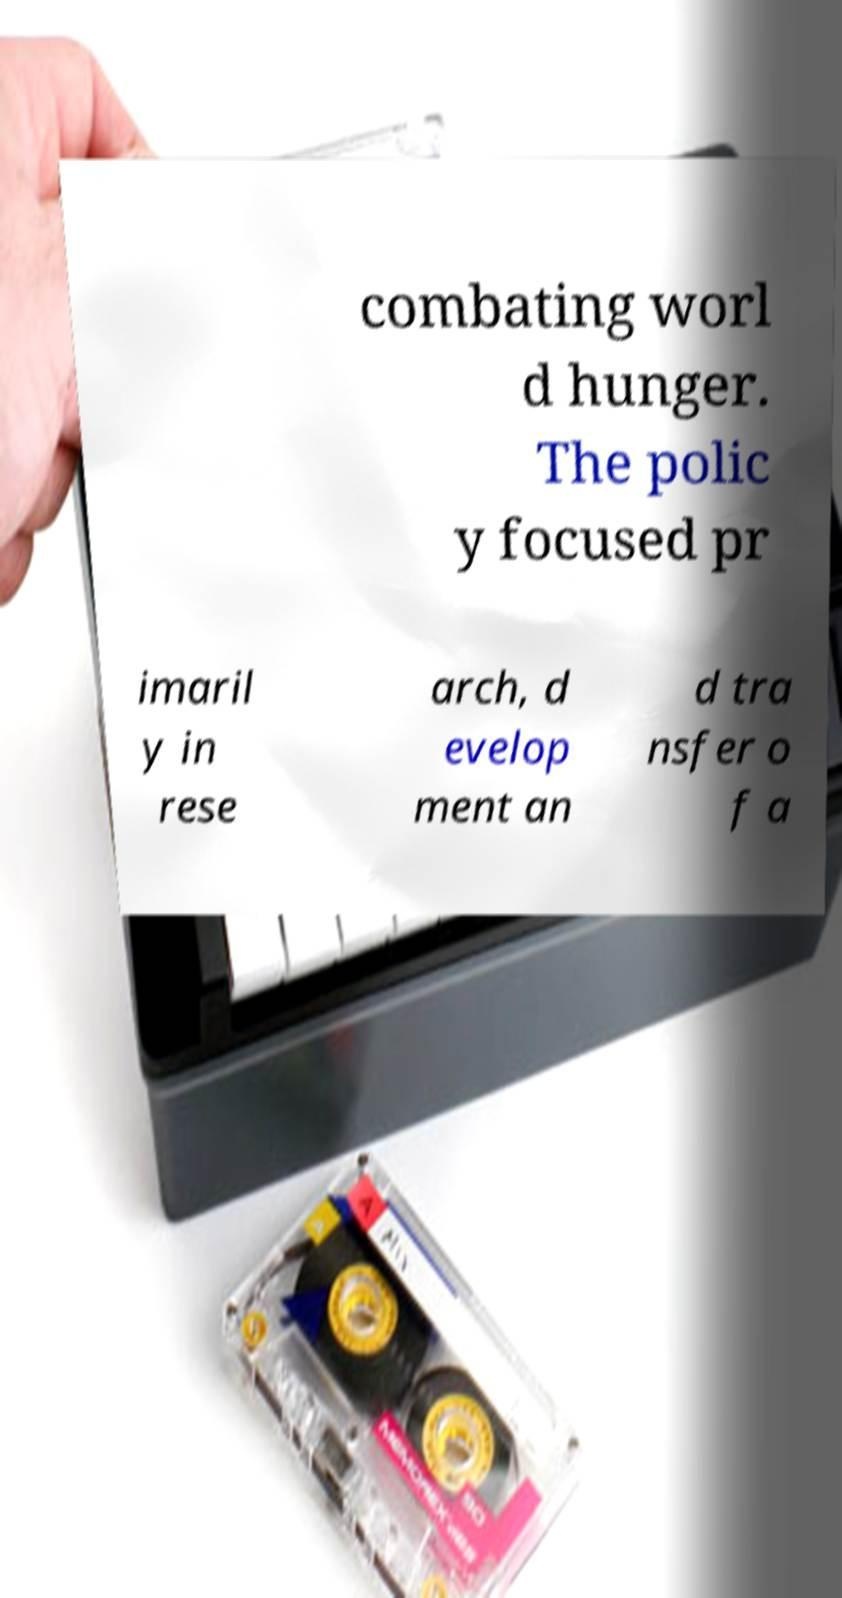Can you read and provide the text displayed in the image?This photo seems to have some interesting text. Can you extract and type it out for me? combating worl d hunger. The polic y focused pr imaril y in rese arch, d evelop ment an d tra nsfer o f a 